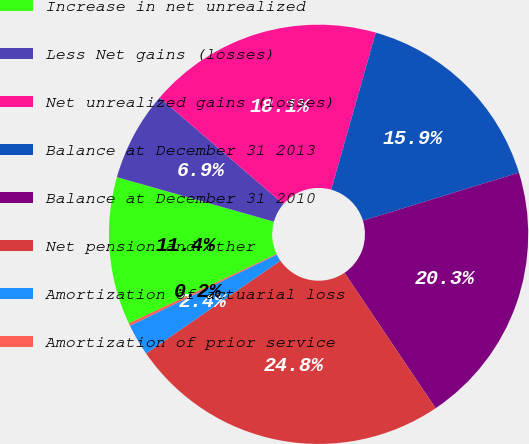Convert chart. <chart><loc_0><loc_0><loc_500><loc_500><pie_chart><fcel>Increase in net unrealized<fcel>Less Net gains (losses)<fcel>Net unrealized gains (losses)<fcel>Balance at December 31 2013<fcel>Balance at December 31 2010<fcel>Net pension and other<fcel>Amortization of actuarial loss<fcel>Amortization of prior service<nl><fcel>11.38%<fcel>6.91%<fcel>18.09%<fcel>15.85%<fcel>20.33%<fcel>24.8%<fcel>2.44%<fcel>0.2%<nl></chart> 